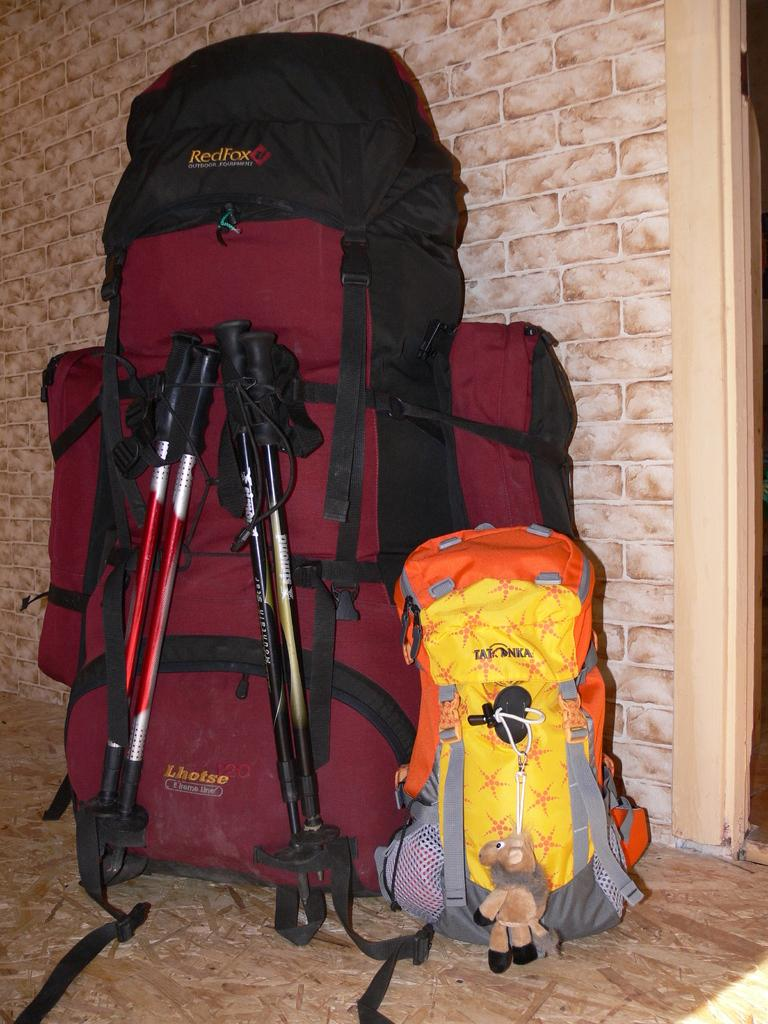Provide a one-sentence caption for the provided image. A red Lhotse backpack with two ski poles folded up and attached to the back. 